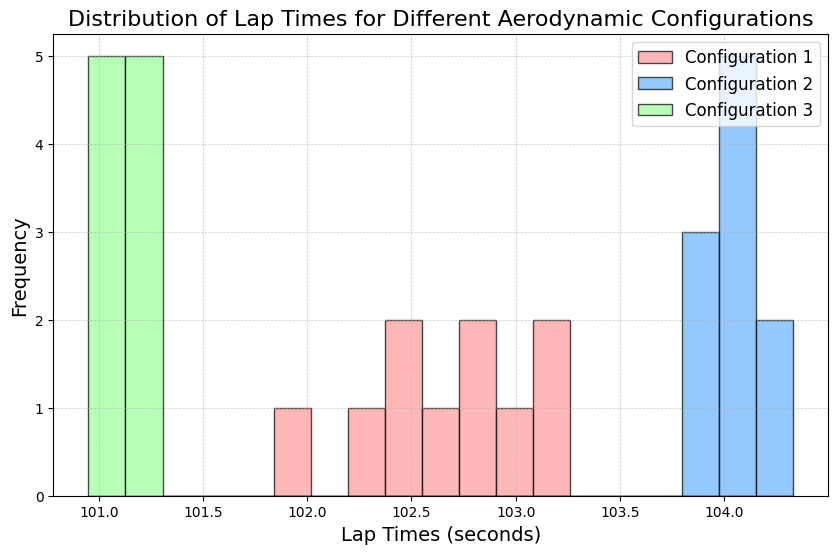Which configuration has the highest peak frequency in lap times? The highest peak frequency in lap times is observed by identifying the tallest bar in the histogram. Configuration 2 (blue) has the highest peak compared to Configuration 1 (red) and Configuration 3 (green).
Answer: Configuration 2 Which configuration has the broader spread of lap times? This can be determined by looking at the width of the distribution for each configuration. Configuration 2 (blue) has a broader spread, extending over a wider range of lap times compared to Configuration 1 (red) and Configuration 3 (green).
Answer: Configuration 2 How do the peak frequencies of Configuration 1 and Configuration 3 compare? To compare the peak frequencies, observe the tallest bars of both configurations. Configuration 1 (red) has a slightly lower peak frequency than Configuration 3 (green).
Answer: Configuration 3 has a slightly higher peak frequency What range of lap times is most frequent for Configuration 3? Identify the position of the tallest bar for Configuration 3 (green). The most frequent lap times for Configuration 3 are around 101.0 to 101.3 seconds.
Answer: 101.0 to 101.3 seconds Which configuration has the narrowest range of lap times? The narrowest range can be seen by identifying the configuration with the smallest spread. Configuration 3 (green) has the narrowest range of lap times.
Answer: Configuration 3 What is the approximate mid-point lap time for Configuration 1? The midpoint or median can be estimated by looking at the central value where most of the lap times are concentrated for Configuration 1 (red). This falls around 102.5 seconds.
Answer: 102.5 seconds Do Configuration 1 and Configuration 2 overlap in their lap time distributions? To determine the overlap, observe if there are common lap time values where both configurations have non-zero frequencies. There is slight overlap in the range of approximately 103.0 to 104.0 seconds.
Answer: Yes Which lap time configuration shows the most skewed distribution? Skewness can be identified by looking at the asymmetry in the distribution. Configuration 2 (blue) shows a more balanced distribution, while Configurations 1 (red) and 3 (green) show slight skews to the right.
Answer: Configuration 1 and Configuration 3 show slight skews If you sum the lap times where Configuration 2 has its highest frequency, what range does this sum fall into? Identify the bin where Configuration 2 (blue) has its highest frequency, then multiply the lap time by the frequency. If the highest frequency occurs around 104.0 seconds with a frequency of about 4, the sum would be 104.0 * 4 = 416.0 seconds.
Answer: Around 416.0 seconds 